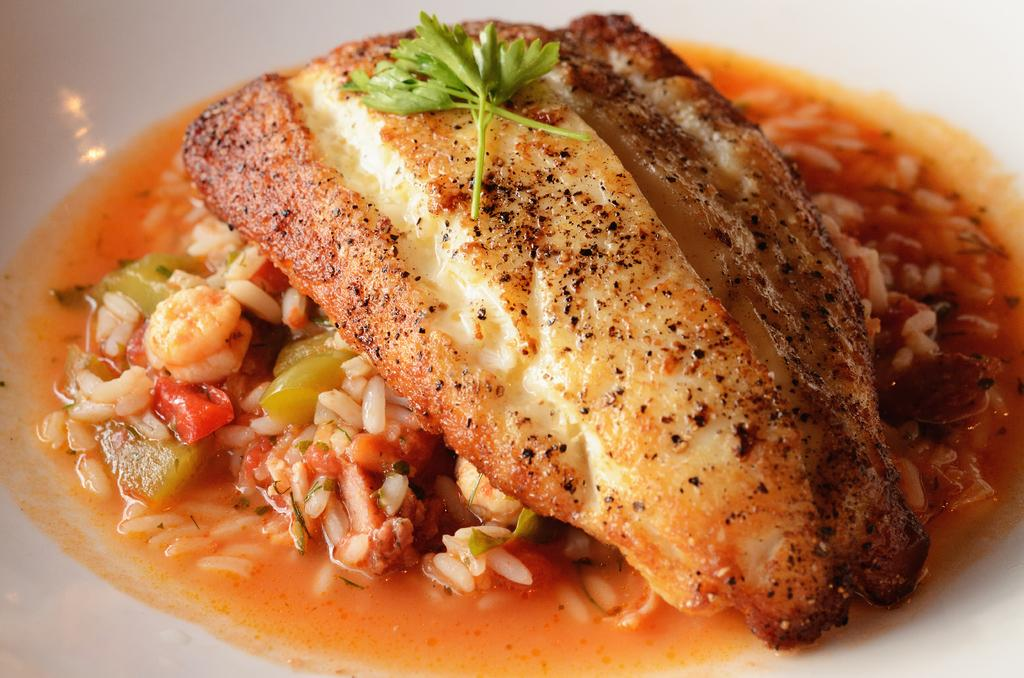What type of food is visible in the image? There is fried fish, rice, tomato pieces, and soup in the image. Are there any other food items present in the image? Yes, there are other food items on a white plate in the image. What type of vest is the bear wearing in the image? There is no bear or vest present in the image. Is the fried fish a work of fiction in the image? The fried fish is not a work of fiction; it is a real food item in the image. 